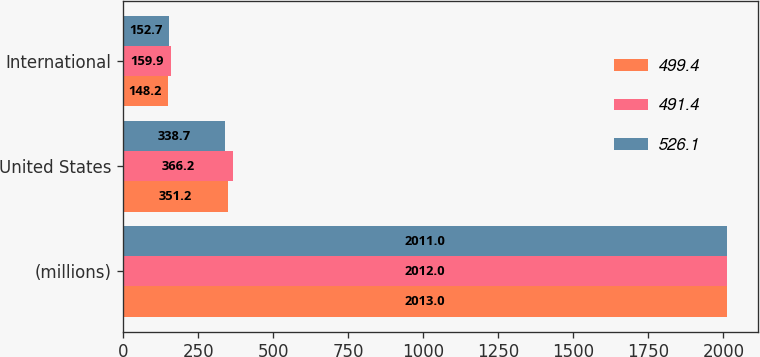Convert chart to OTSL. <chart><loc_0><loc_0><loc_500><loc_500><stacked_bar_chart><ecel><fcel>(millions)<fcel>United States<fcel>International<nl><fcel>499.4<fcel>2013<fcel>351.2<fcel>148.2<nl><fcel>491.4<fcel>2012<fcel>366.2<fcel>159.9<nl><fcel>526.1<fcel>2011<fcel>338.7<fcel>152.7<nl></chart> 